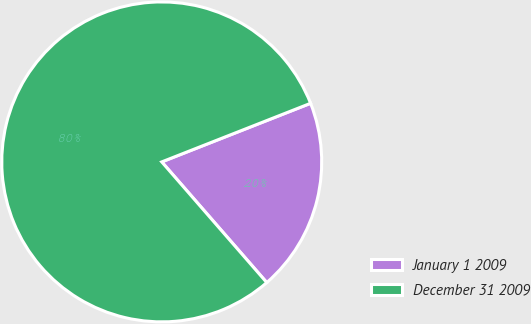Convert chart. <chart><loc_0><loc_0><loc_500><loc_500><pie_chart><fcel>January 1 2009<fcel>December 31 2009<nl><fcel>19.57%<fcel>80.43%<nl></chart> 